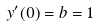<formula> <loc_0><loc_0><loc_500><loc_500>y ^ { \prime } ( 0 ) = b = 1</formula> 